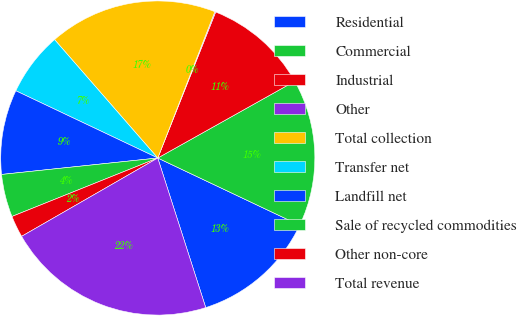Convert chart to OTSL. <chart><loc_0><loc_0><loc_500><loc_500><pie_chart><fcel>Residential<fcel>Commercial<fcel>Industrial<fcel>Other<fcel>Total collection<fcel>Transfer net<fcel>Landfill net<fcel>Sale of recycled commodities<fcel>Other non-core<fcel>Total revenue<nl><fcel>13.02%<fcel>15.17%<fcel>10.86%<fcel>0.09%<fcel>17.33%<fcel>6.55%<fcel>8.71%<fcel>4.4%<fcel>2.24%<fcel>21.63%<nl></chart> 